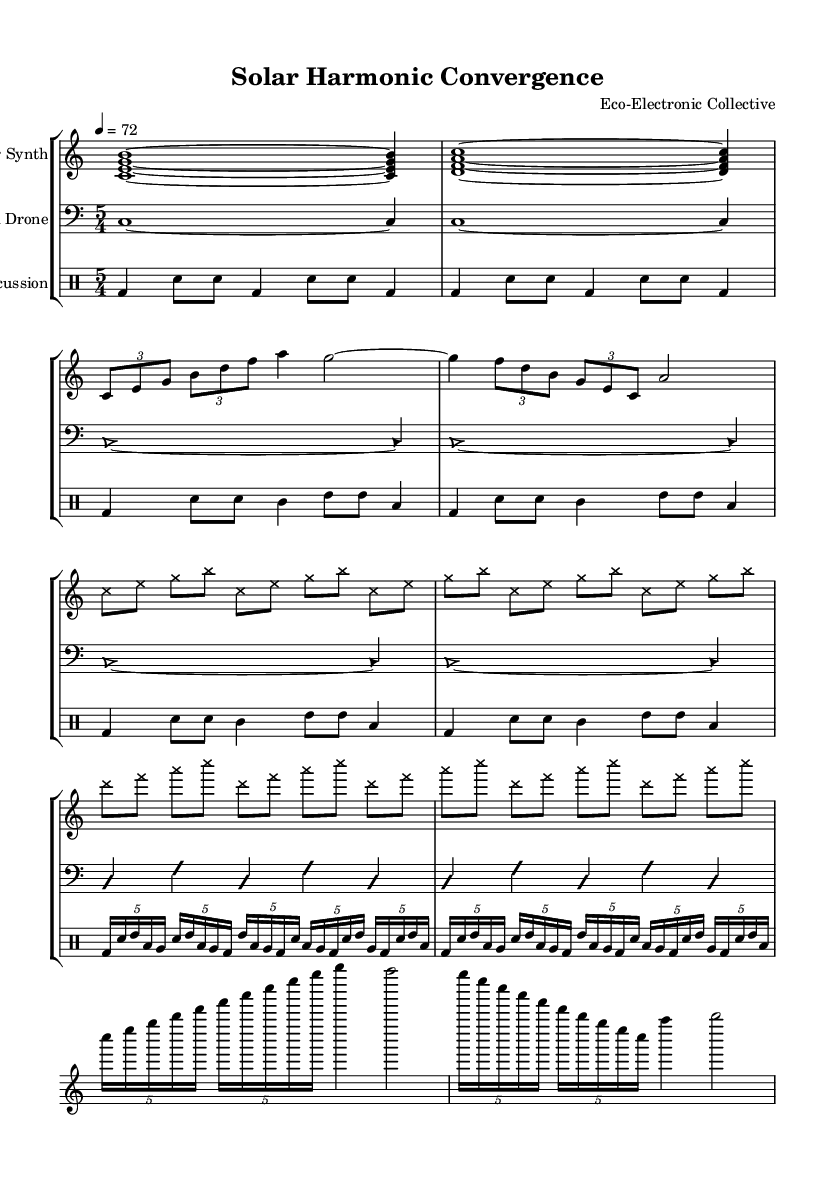What is the time signature shown in the music? The time signature is indicated at the beginning of the score and is marked as 5/4, which means there are five beats per measure.
Answer: 5/4 What is the tempo marking in the score? The tempo is specified as "4 = 72," meaning that there are 72 quarter notes per minute, guiding the speed of the piece.
Answer: 72 What is the primary instrument used in the first section? In the introductory measures, the Solar Synth plays harmonies using chords, signifying its primary role at the beginning.
Answer: Solar Synth How many measures are in Section A? Section A consists of 4 measures, as can be counted in the score after the introductory segment.
Answer: 4 What type of note head style is used in the aleatoric section? The note head style changed to 'cross' for the aleatoric section, which denotes a specific approach to note representation in that part of the score.
Answer: cross What instruments are included in the score? The score includes a Solar Synth, Wind Drone, and Percussion, collectively forming the ensemble for this piece.
Answer: Solar Synth, Wind Drone, Percussion How many repetitions occur in the percussion section? The percussion section features several repetitions, specifically structured in multipart measures, and can be systematically counted, showing complexity and layering.
Answer: 4 